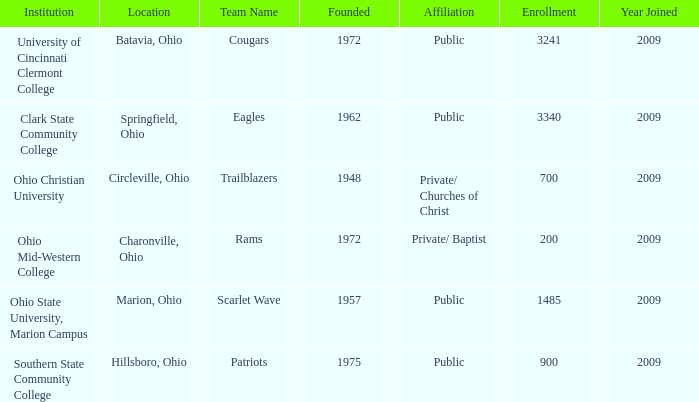How many occurrences are there for initiated when the location was springfield, ohio? 1.0. Could you help me parse every detail presented in this table? {'header': ['Institution', 'Location', 'Team Name', 'Founded', 'Affiliation', 'Enrollment', 'Year Joined'], 'rows': [['University of Cincinnati Clermont College', 'Batavia, Ohio', 'Cougars', '1972', 'Public', '3241', '2009'], ['Clark State Community College', 'Springfield, Ohio', 'Eagles', '1962', 'Public', '3340', '2009'], ['Ohio Christian University', 'Circleville, Ohio', 'Trailblazers', '1948', 'Private/ Churches of Christ', '700', '2009'], ['Ohio Mid-Western College', 'Charonville, Ohio', 'Rams', '1972', 'Private/ Baptist', '200', '2009'], ['Ohio State University, Marion Campus', 'Marion, Ohio', 'Scarlet Wave', '1957', 'Public', '1485', '2009'], ['Southern State Community College', 'Hillsboro, Ohio', 'Patriots', '1975', 'Public', '900', '2009']]} 